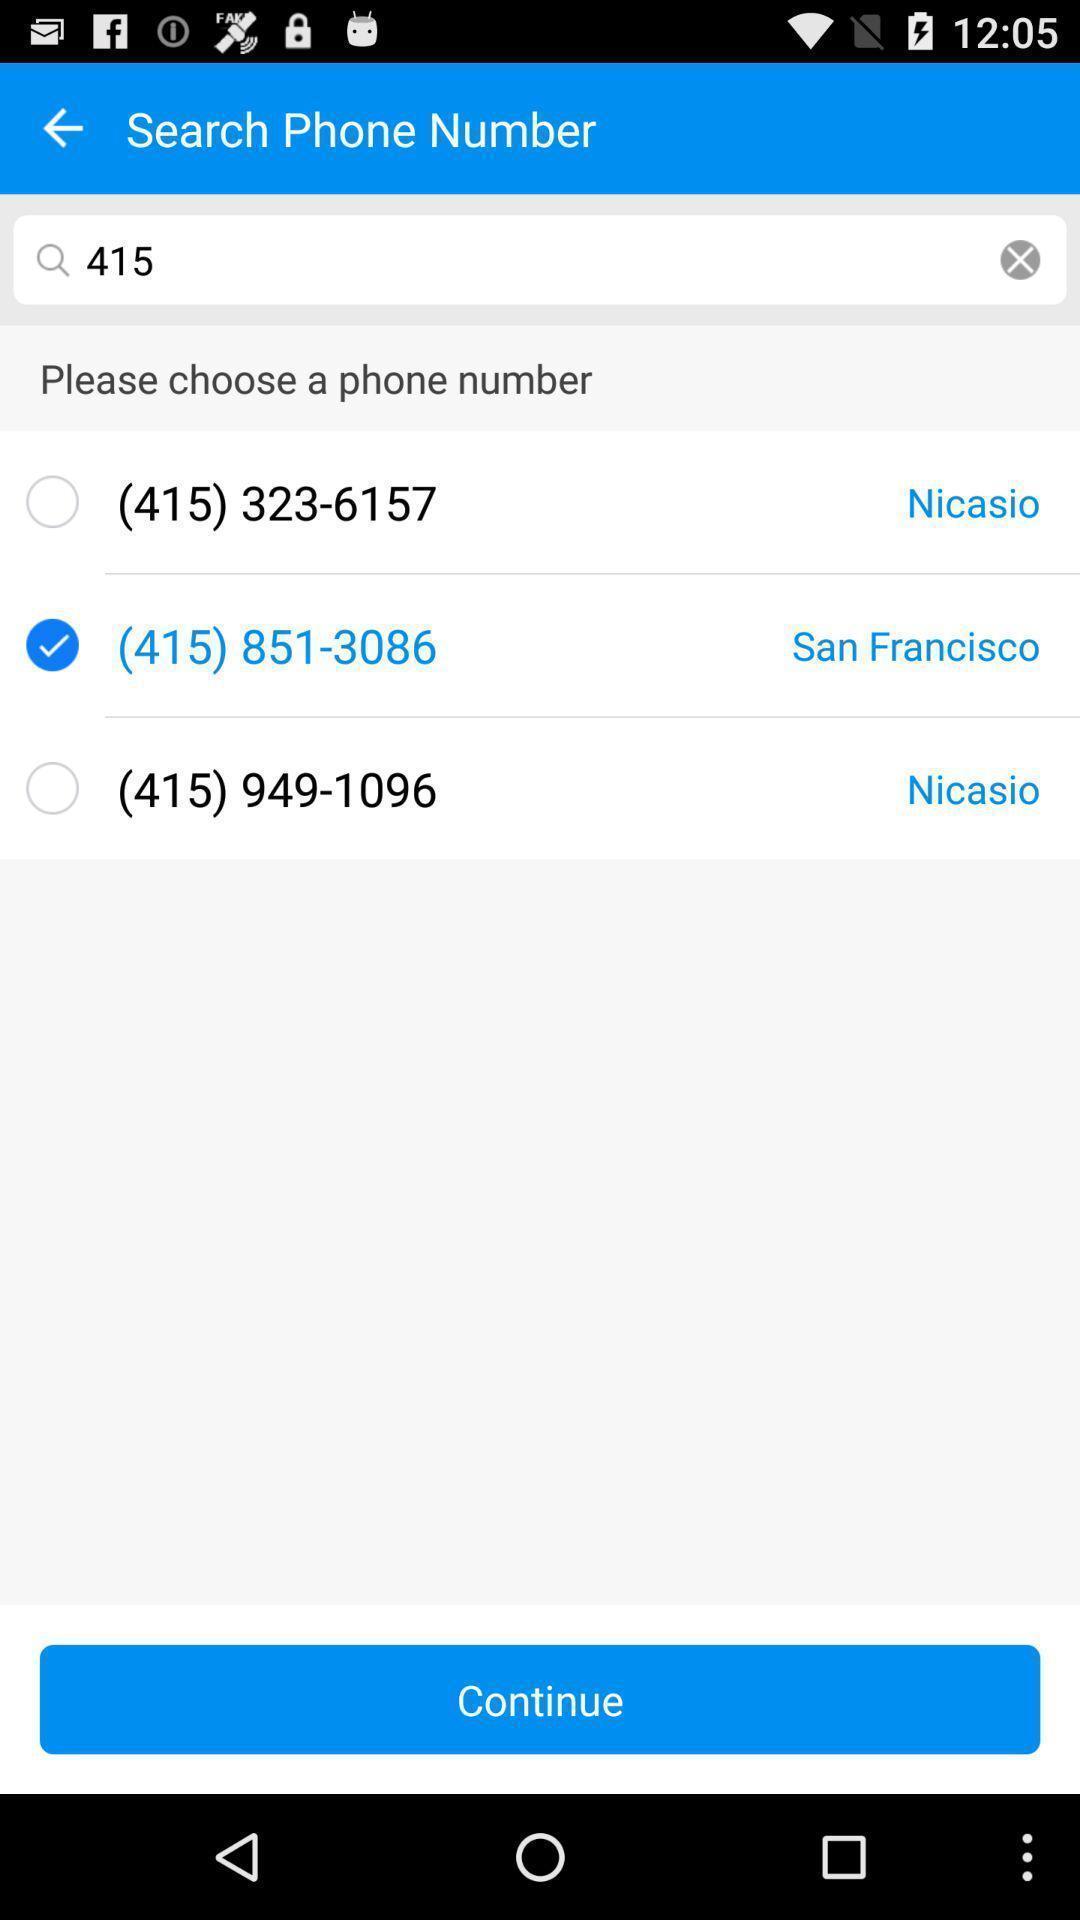Explain the elements present in this screenshot. Search page for searching a contact. 